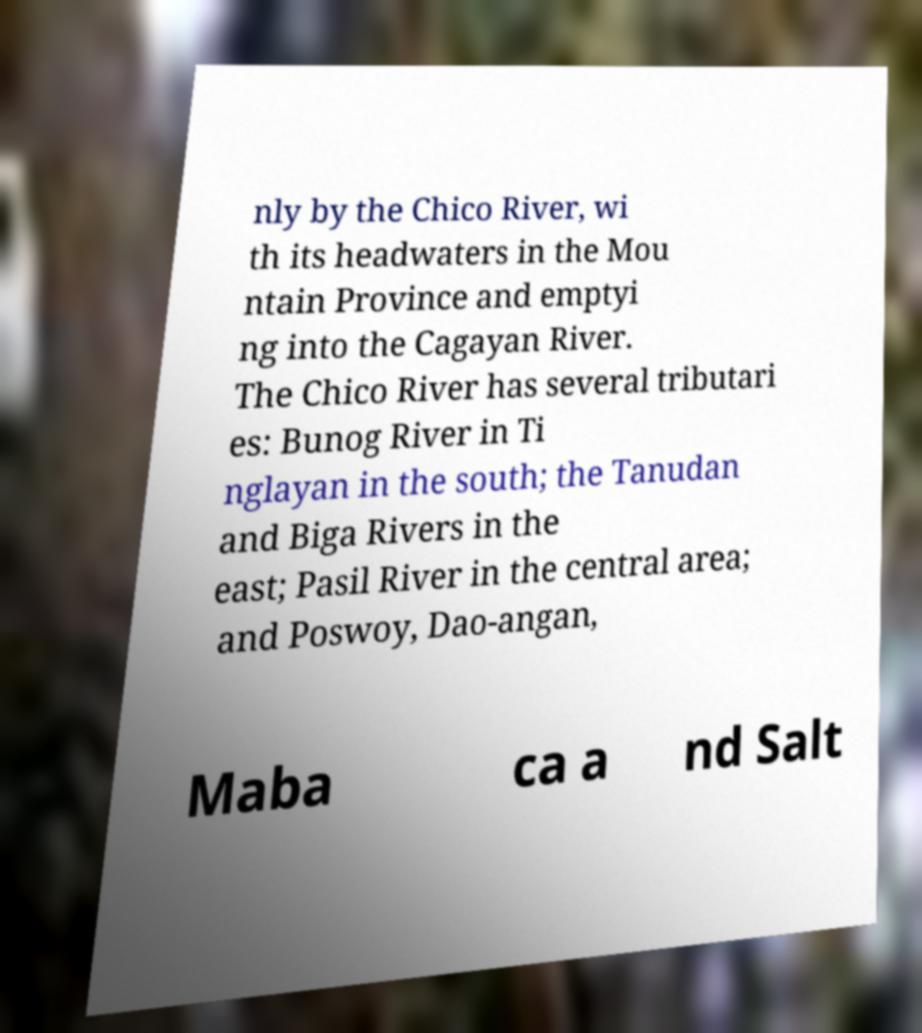Can you accurately transcribe the text from the provided image for me? nly by the Chico River, wi th its headwaters in the Mou ntain Province and emptyi ng into the Cagayan River. The Chico River has several tributari es: Bunog River in Ti nglayan in the south; the Tanudan and Biga Rivers in the east; Pasil River in the central area; and Poswoy, Dao-angan, Maba ca a nd Salt 